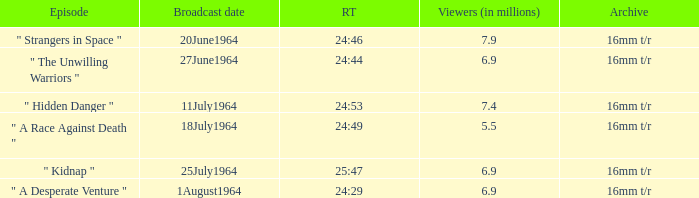What episode aired on 11july1964? " Hidden Danger ". 